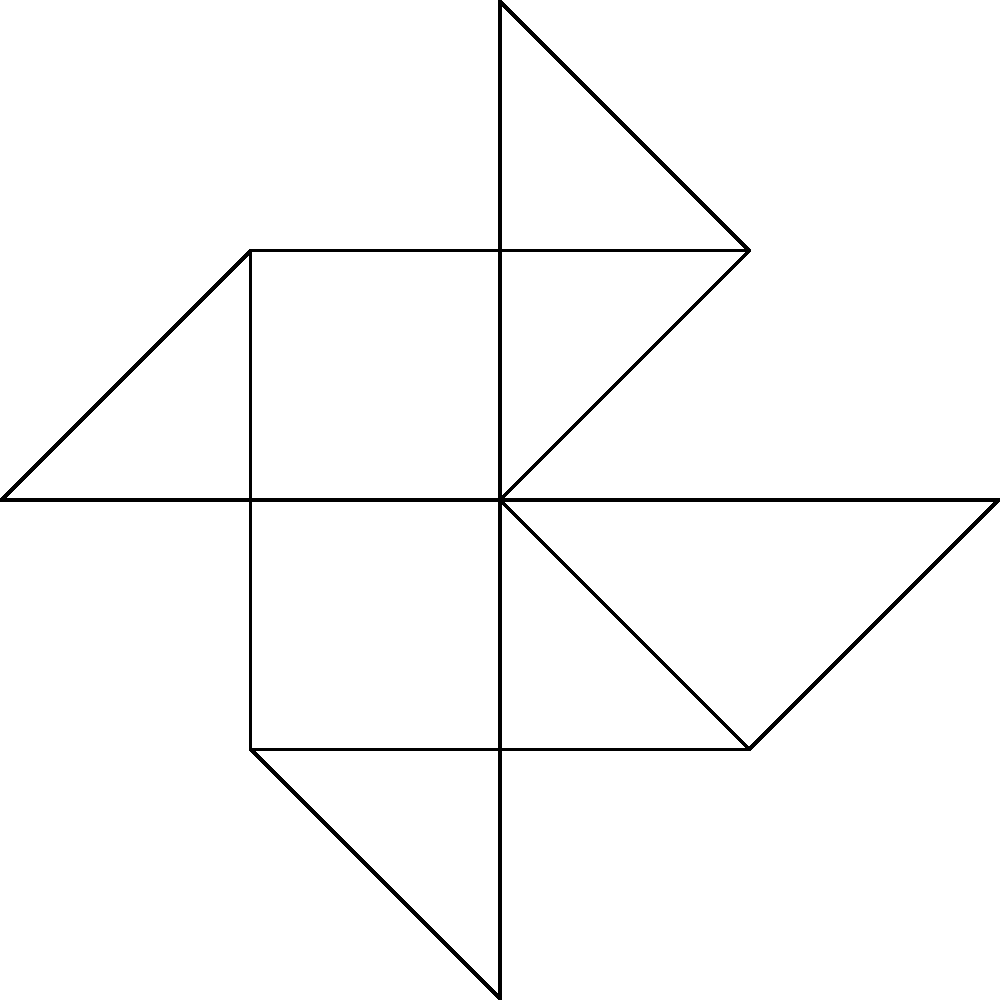In a mental health support group network, patients are represented by vertices, and interactions between patients are represented by edges. Given the network graph above, what is the degree centrality of vertex $v_0$, and what does this imply about the patient's role in the group? To answer this question, we need to follow these steps:

1. Understand degree centrality:
   Degree centrality is a measure of the number of direct connections a node has in a network.

2. Count the connections for vertex $v_0$:
   - $v_0$ is connected to $v_1$, $v_2$, $v_3$, $v_4$, $v_5$, $v_6$, $v_7$, and $v_8$.
   - The total number of connections is 8.

3. Calculate the degree centrality:
   - In this case, the degree centrality is simply the number of connections, which is 8.

4. Interpret the result:
   - A high degree centrality (8 out of 9 possible connections) indicates that the patient represented by $v_0$ is highly connected within the group.
   - This patient likely plays a central role in the support group, possibly as a facilitator, long-term member, or someone who is particularly active in group discussions and interactions.
   - From a mental health perspective, this patient may be a key figure in providing peer support, sharing experiences, or connecting newer members to the group.

5. Consider the implications for wearable device development:
   - This type of network analysis could be valuable for designing wearable devices that track social interactions and their impact on mental health.
   - Devices could potentially identify key individuals in support networks and monitor how their interactions affect group dynamics and individual well-being.
Answer: Degree centrality: 8; implies central role in group support and interactions 